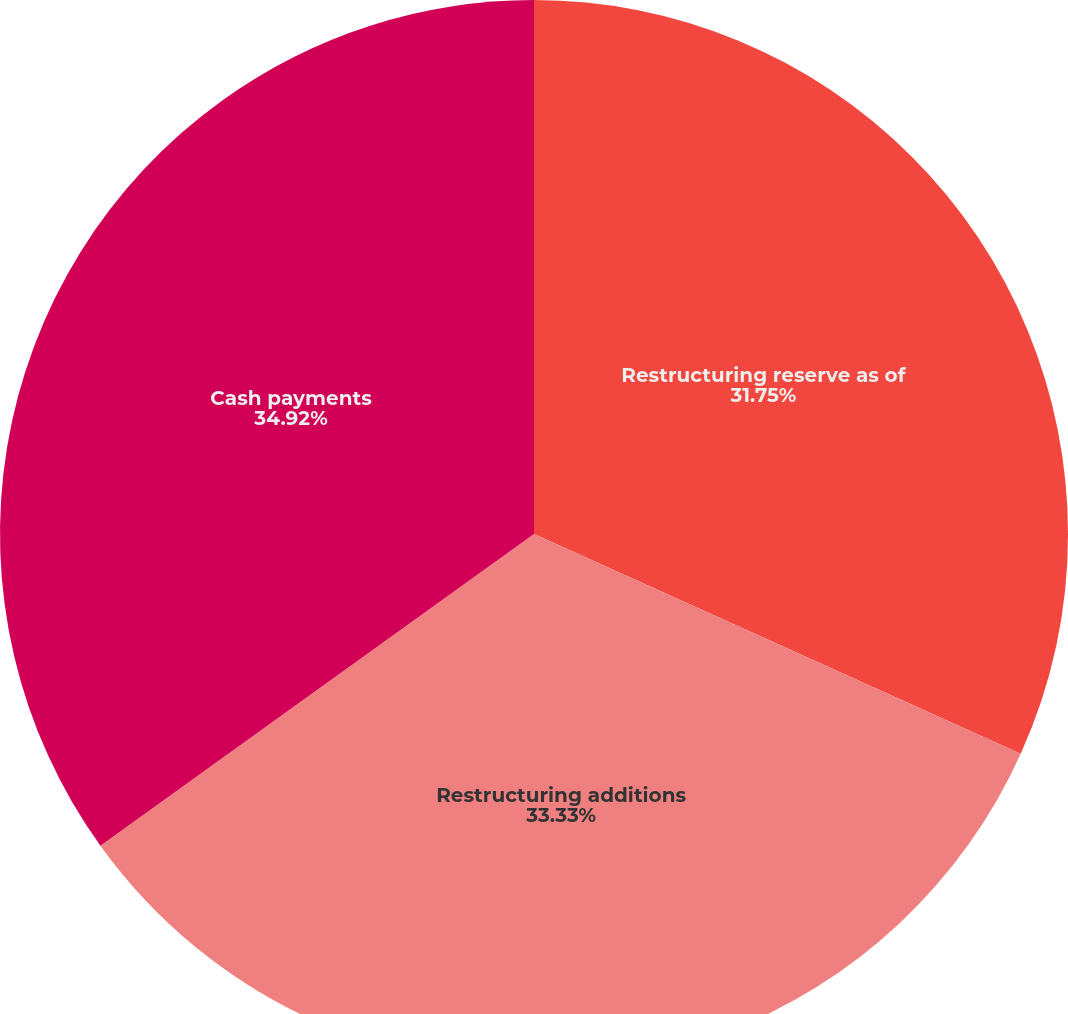Convert chart to OTSL. <chart><loc_0><loc_0><loc_500><loc_500><pie_chart><fcel>Restructuring reserve as of<fcel>Restructuring additions<fcel>Cash payments<nl><fcel>31.75%<fcel>33.33%<fcel>34.92%<nl></chart> 